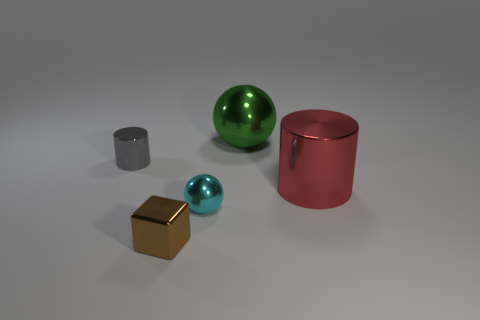There is a large object to the left of the big red object; is its shape the same as the small object that is behind the large red object?
Ensure brevity in your answer.  No. What is the material of the small brown object?
Your answer should be very brief. Metal. Is there anything else that has the same color as the small cube?
Offer a terse response. No. There is a red cylinder that is made of the same material as the gray cylinder; what is its size?
Keep it short and to the point. Large. What number of big things are either red objects or cyan matte balls?
Make the answer very short. 1. What size is the thing in front of the sphere that is in front of the cylinder that is on the right side of the cyan metal object?
Ensure brevity in your answer.  Small. What number of blue shiny blocks have the same size as the green thing?
Make the answer very short. 0. What number of objects are either brown blocks or metal objects that are in front of the large green metal ball?
Your answer should be compact. 4. The large red object is what shape?
Your answer should be very brief. Cylinder. What is the color of the other metallic thing that is the same size as the red metallic thing?
Give a very brief answer. Green. 